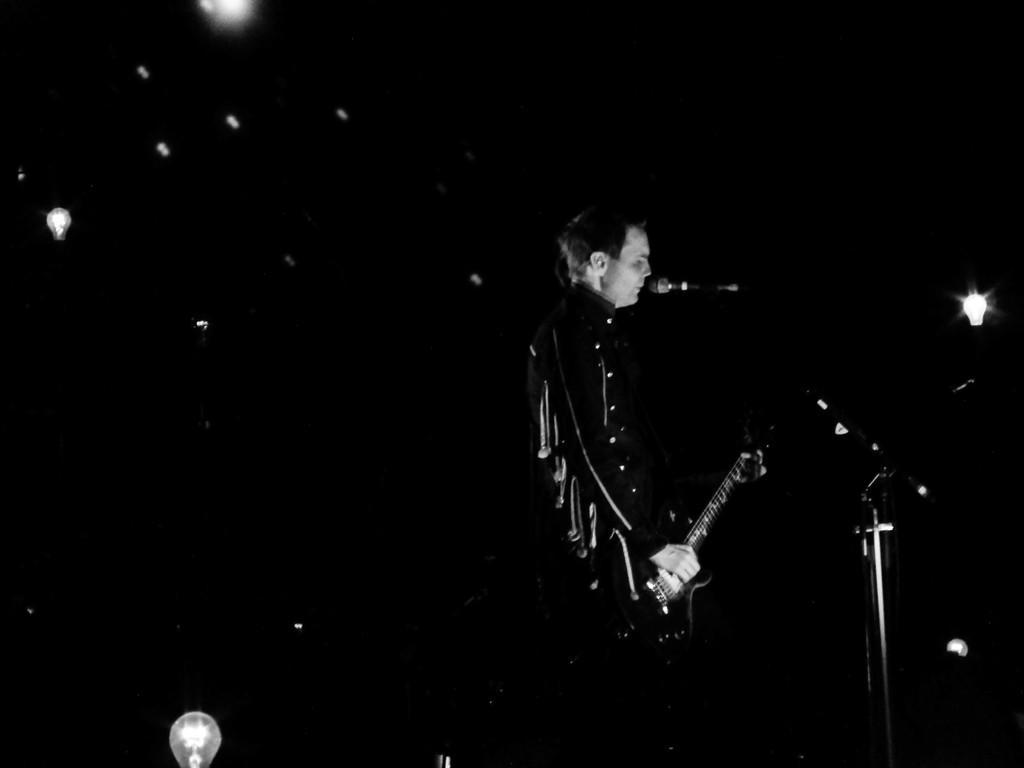How would you summarize this image in a sentence or two? This picture seems to be of inside. In the center there is a person standing, playing guitar and seems to be singing. There is a microphone attached to the stand. In the background we can see the lights. 